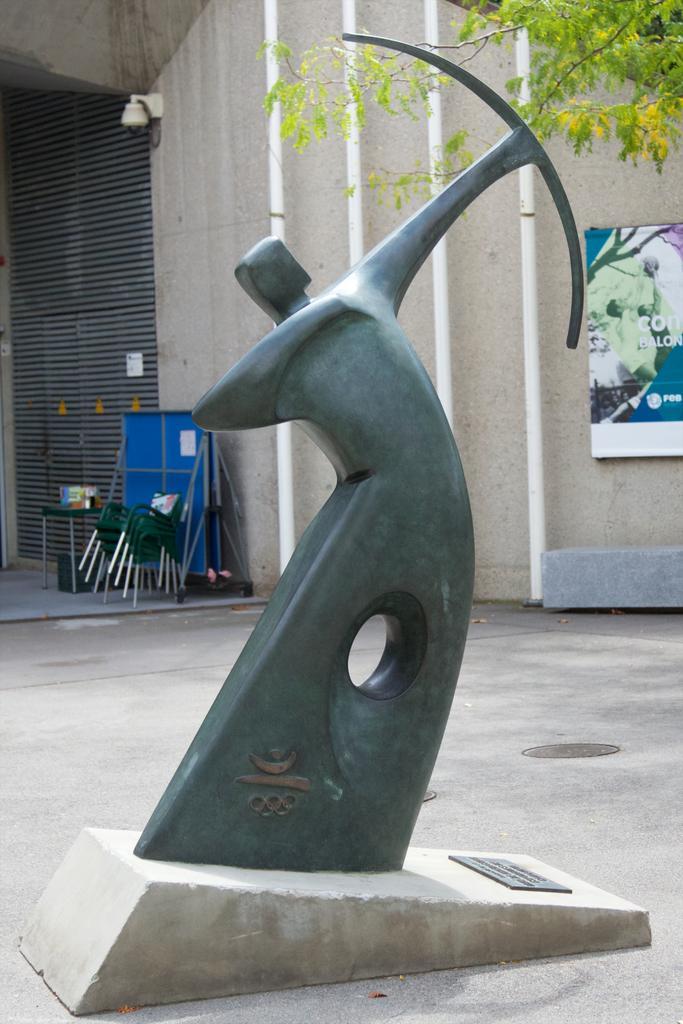Can you describe this image briefly? In this image there is a sculpture that resembles a person, there is ground towards the bottom of the image, there are chairs, there are tables, there are objects on the table, there is a wall, there is a board towards the right of the image, there is text on the board, there is a tree towards the right of the image, there is a security camera on the wall, there are pipes towards the top of the image. 